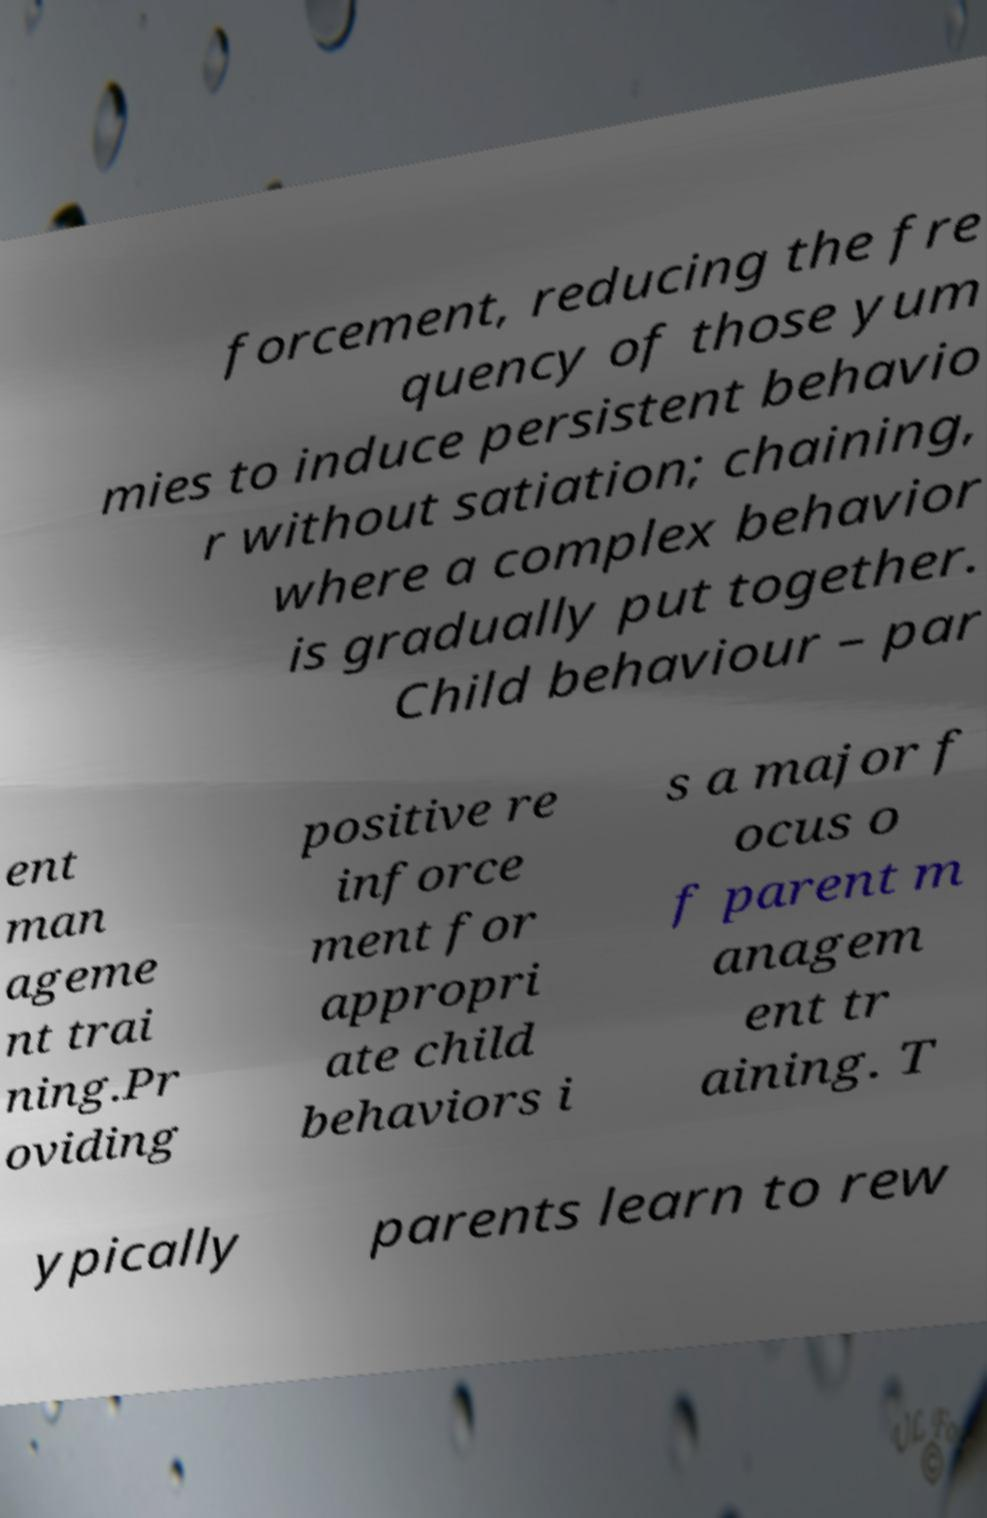What messages or text are displayed in this image? I need them in a readable, typed format. forcement, reducing the fre quency of those yum mies to induce persistent behavio r without satiation; chaining, where a complex behavior is gradually put together. Child behaviour – par ent man ageme nt trai ning.Pr oviding positive re inforce ment for appropri ate child behaviors i s a major f ocus o f parent m anagem ent tr aining. T ypically parents learn to rew 